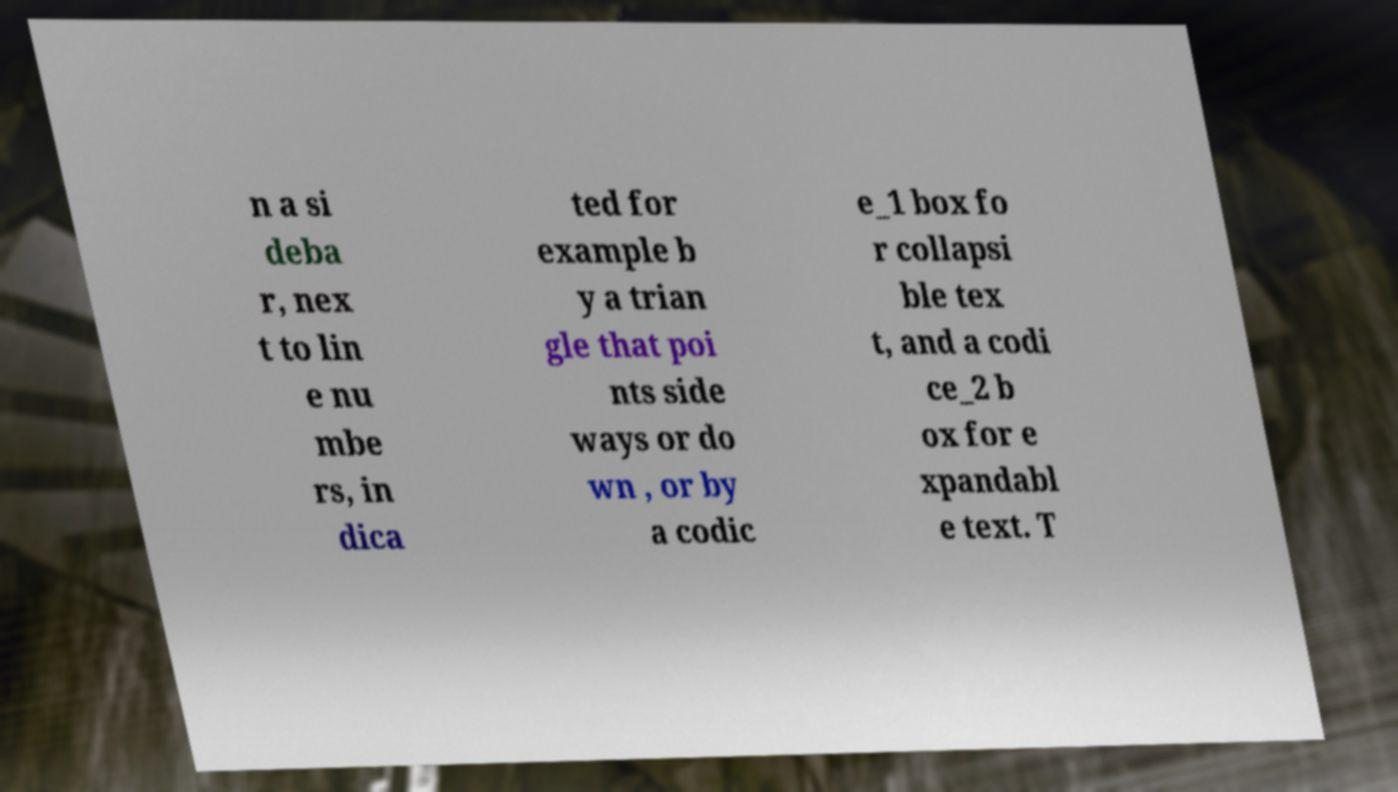Please read and relay the text visible in this image. What does it say? n a si deba r, nex t to lin e nu mbe rs, in dica ted for example b y a trian gle that poi nts side ways or do wn , or by a codic e_1 box fo r collapsi ble tex t, and a codi ce_2 b ox for e xpandabl e text. T 